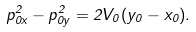<formula> <loc_0><loc_0><loc_500><loc_500>p _ { 0 x } ^ { 2 } - p _ { 0 y } ^ { 2 } = 2 V _ { 0 } ( y _ { 0 } - x _ { 0 } ) .</formula> 